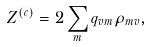Convert formula to latex. <formula><loc_0><loc_0><loc_500><loc_500>Z ^ { ( c ) } = 2 \sum _ { m } q _ { v m } \rho _ { m v } ,</formula> 